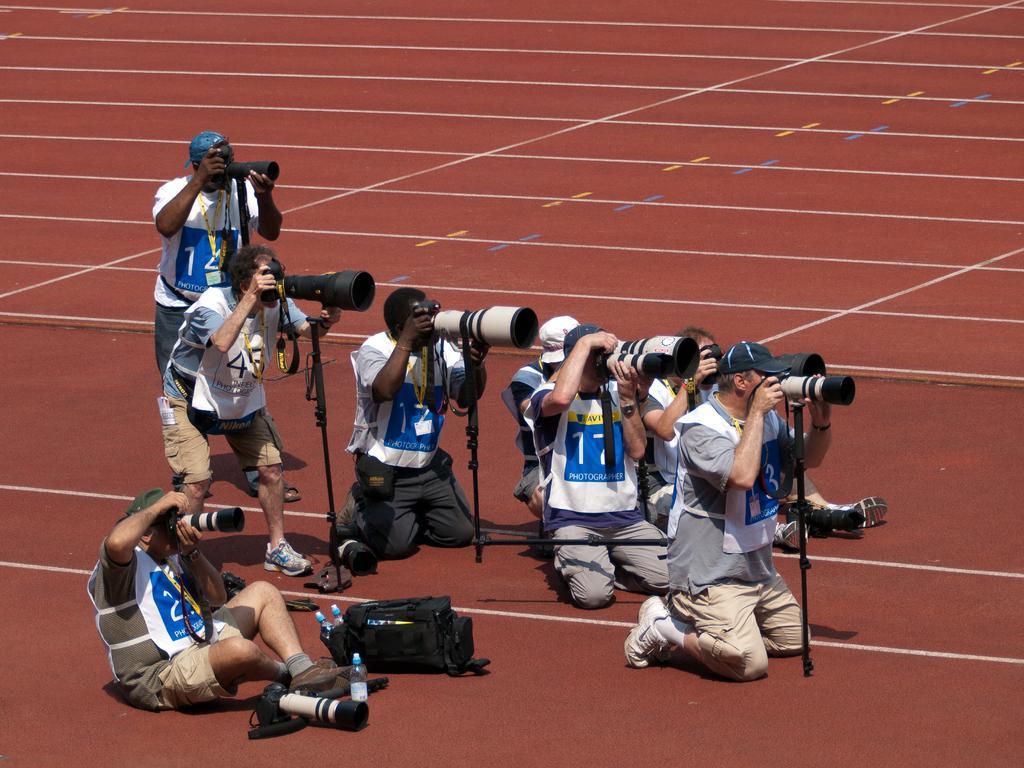Please provide a concise description of this image. In the picture we can see a brown color surface on it, we can see some people are sitting on the knees and two people are standing, they all are capturing something with the cameras. 